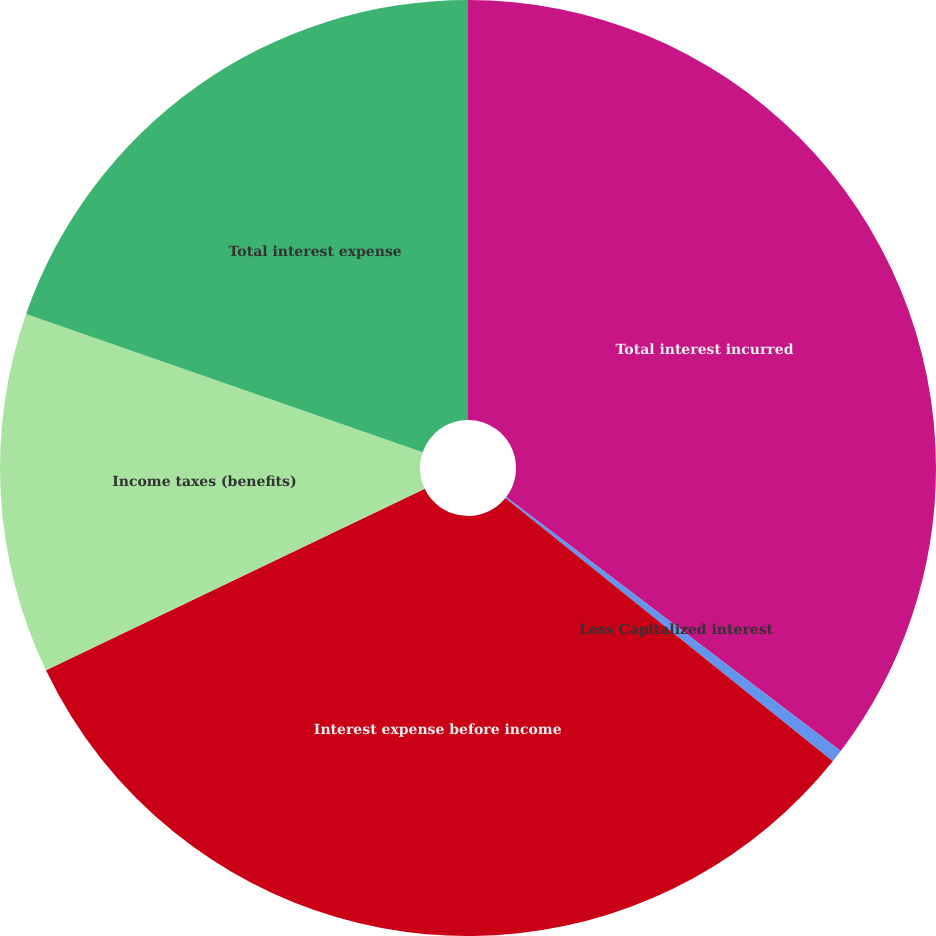Convert chart. <chart><loc_0><loc_0><loc_500><loc_500><pie_chart><fcel>Total interest incurred<fcel>Less Capitalized interest<fcel>Interest expense before income<fcel>Income taxes (benefits)<fcel>Total interest expense<nl><fcel>35.33%<fcel>0.44%<fcel>32.11%<fcel>12.45%<fcel>19.66%<nl></chart> 